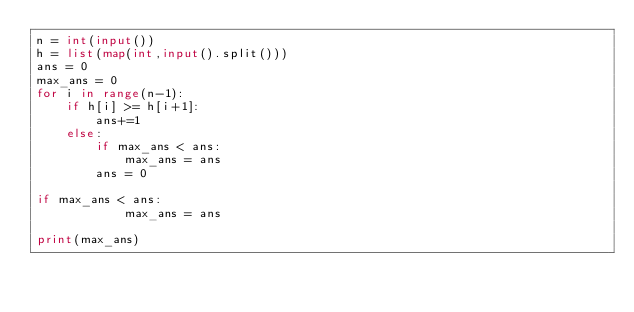<code> <loc_0><loc_0><loc_500><loc_500><_Python_>n = int(input())
h = list(map(int,input().split()))
ans = 0
max_ans = 0
for i in range(n-1):
    if h[i] >= h[i+1]:
        ans+=1
    else:
        if max_ans < ans:
            max_ans = ans
        ans = 0
        
if max_ans < ans:
            max_ans = ans
            
print(max_ans)</code> 